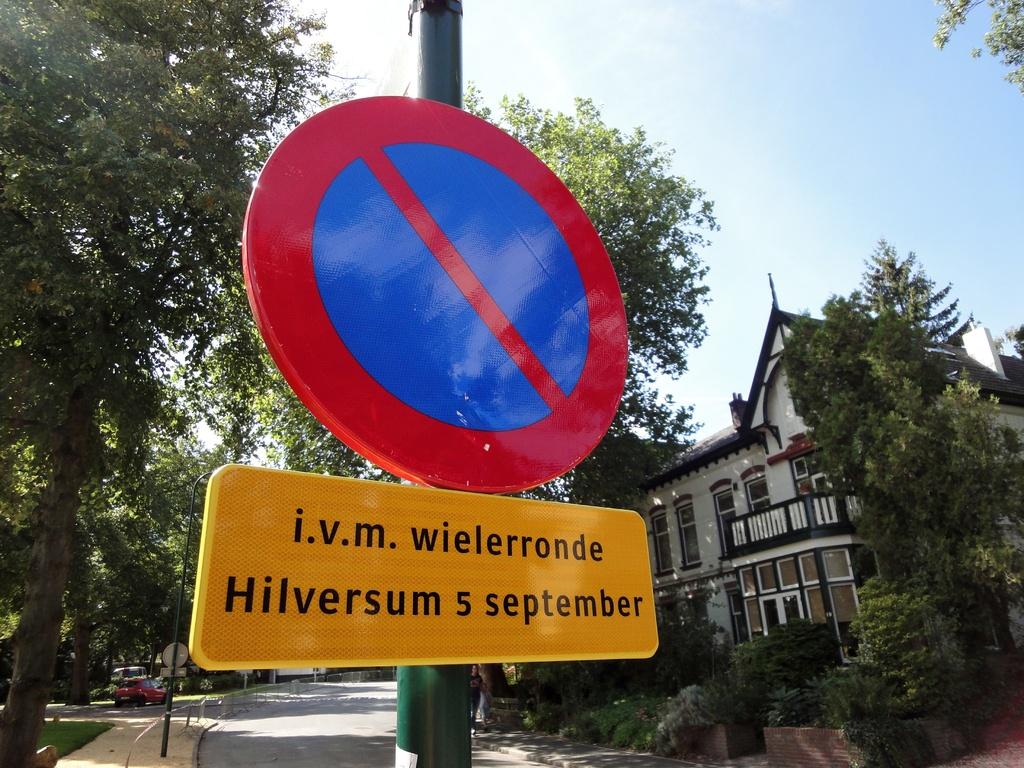What date is listed?
Offer a very short reply. 5 september. What month is on the sign?
Keep it short and to the point. September. 